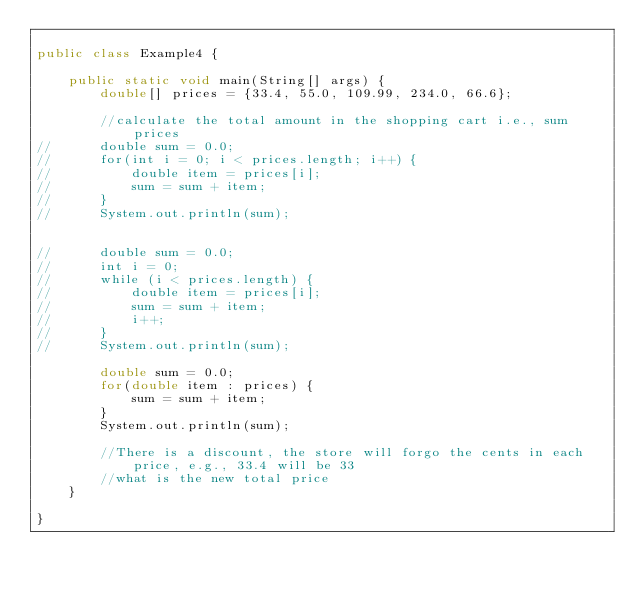Convert code to text. <code><loc_0><loc_0><loc_500><loc_500><_Java_>
public class Example4 {

	public static void main(String[] args) {
		double[] prices = {33.4, 55.0, 109.99, 234.0, 66.6};

		//calculate the total amount in the shopping cart i.e., sum prices
//		double sum = 0.0;
//		for(int i = 0; i < prices.length; i++) {
//			double item = prices[i];
//			sum = sum + item;
//		}
//		System.out.println(sum);
		

//		double sum = 0.0;
//		int i = 0;
//		while (i < prices.length) {
//			double item = prices[i];
//			sum = sum + item;
//			i++;
//		}
//		System.out.println(sum);
		
		double sum = 0.0;
		for(double item : prices) {
			sum = sum + item;
		}
		System.out.println(sum);
		
		//There is a discount, the store will forgo the cents in each price, e.g., 33.4 will be 33
		//what is the new total price
	}
 
}
</code> 